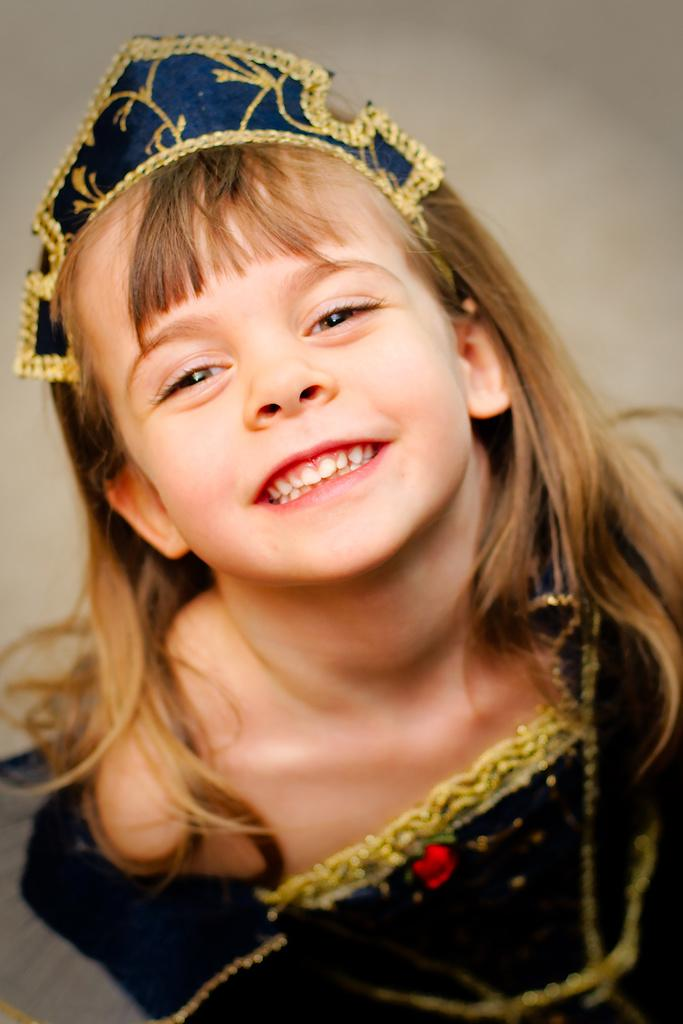Who is the main subject in the image? There is a girl in the image. What is the girl wearing? The girl is wearing a blue dress and a crown. What expression does the girl have on her face? The girl is smiling. What type of business does the girl run in the image? There is no indication of a business in the image; it simply shows a girl wearing a blue dress, a crown, and smiling. 